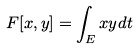<formula> <loc_0><loc_0><loc_500><loc_500>F [ x , y ] = \int _ { E } x y d t</formula> 